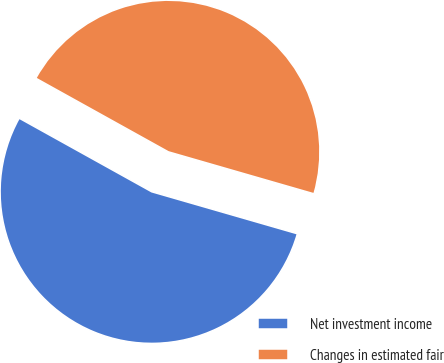Convert chart to OTSL. <chart><loc_0><loc_0><loc_500><loc_500><pie_chart><fcel>Net investment income<fcel>Changes in estimated fair<nl><fcel>53.6%<fcel>46.4%<nl></chart> 